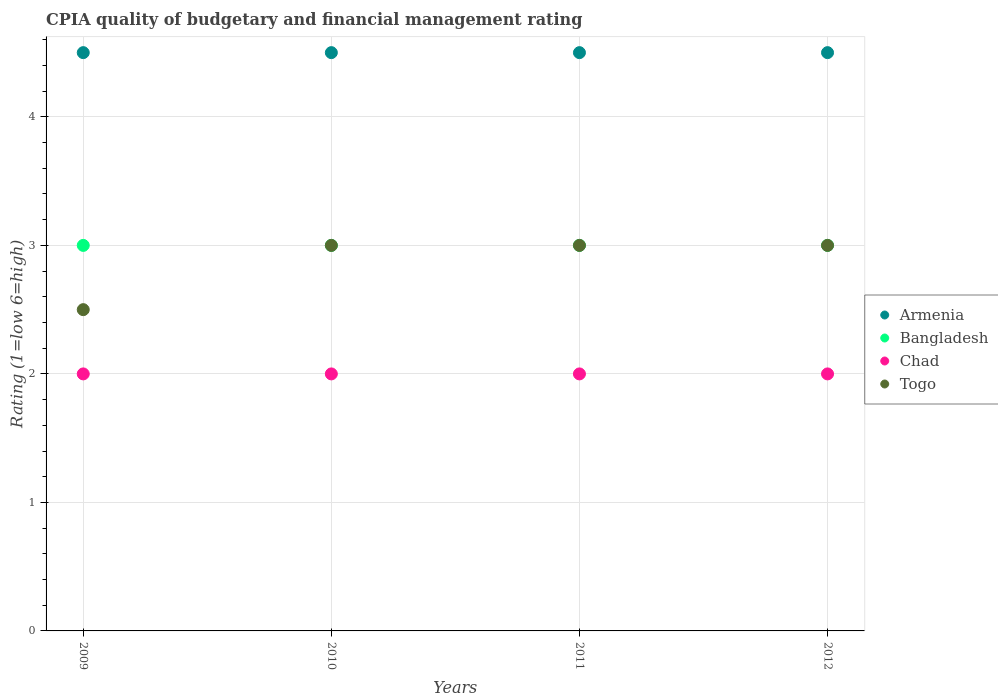Is the number of dotlines equal to the number of legend labels?
Keep it short and to the point. Yes. Across all years, what is the maximum CPIA rating in Togo?
Offer a very short reply. 3. Across all years, what is the minimum CPIA rating in Bangladesh?
Keep it short and to the point. 3. What is the total CPIA rating in Bangladesh in the graph?
Make the answer very short. 12. What is the difference between the CPIA rating in Bangladesh in 2011 and that in 2012?
Give a very brief answer. 0. What is the difference between the highest and the second highest CPIA rating in Togo?
Give a very brief answer. 0. In how many years, is the CPIA rating in Chad greater than the average CPIA rating in Chad taken over all years?
Your answer should be compact. 0. Is it the case that in every year, the sum of the CPIA rating in Chad and CPIA rating in Togo  is greater than the CPIA rating in Bangladesh?
Make the answer very short. Yes. Does the CPIA rating in Armenia monotonically increase over the years?
Ensure brevity in your answer.  No. Is the CPIA rating in Armenia strictly greater than the CPIA rating in Chad over the years?
Offer a very short reply. Yes. Is the CPIA rating in Bangladesh strictly less than the CPIA rating in Chad over the years?
Your answer should be very brief. No. How many dotlines are there?
Your answer should be compact. 4. How many years are there in the graph?
Your response must be concise. 4. Are the values on the major ticks of Y-axis written in scientific E-notation?
Provide a short and direct response. No. Does the graph contain grids?
Ensure brevity in your answer.  Yes. Where does the legend appear in the graph?
Your answer should be very brief. Center right. How many legend labels are there?
Provide a short and direct response. 4. What is the title of the graph?
Provide a succinct answer. CPIA quality of budgetary and financial management rating. What is the Rating (1=low 6=high) of Bangladesh in 2009?
Keep it short and to the point. 3. What is the Rating (1=low 6=high) of Chad in 2009?
Give a very brief answer. 2. What is the Rating (1=low 6=high) of Chad in 2010?
Offer a very short reply. 2. What is the Rating (1=low 6=high) of Togo in 2010?
Make the answer very short. 3. What is the Rating (1=low 6=high) of Bangladesh in 2011?
Offer a very short reply. 3. What is the Rating (1=low 6=high) in Togo in 2011?
Offer a terse response. 3. What is the Rating (1=low 6=high) of Armenia in 2012?
Your response must be concise. 4.5. Across all years, what is the maximum Rating (1=low 6=high) in Armenia?
Give a very brief answer. 4.5. Across all years, what is the maximum Rating (1=low 6=high) of Bangladesh?
Give a very brief answer. 3. Across all years, what is the maximum Rating (1=low 6=high) in Chad?
Offer a terse response. 2. Across all years, what is the maximum Rating (1=low 6=high) of Togo?
Provide a short and direct response. 3. Across all years, what is the minimum Rating (1=low 6=high) of Bangladesh?
Provide a succinct answer. 3. Across all years, what is the minimum Rating (1=low 6=high) in Chad?
Offer a very short reply. 2. What is the total Rating (1=low 6=high) of Togo in the graph?
Ensure brevity in your answer.  11.5. What is the difference between the Rating (1=low 6=high) of Armenia in 2009 and that in 2010?
Provide a short and direct response. 0. What is the difference between the Rating (1=low 6=high) of Chad in 2009 and that in 2010?
Offer a very short reply. 0. What is the difference between the Rating (1=low 6=high) in Bangladesh in 2009 and that in 2011?
Give a very brief answer. 0. What is the difference between the Rating (1=low 6=high) in Chad in 2009 and that in 2011?
Ensure brevity in your answer.  0. What is the difference between the Rating (1=low 6=high) of Togo in 2009 and that in 2011?
Provide a succinct answer. -0.5. What is the difference between the Rating (1=low 6=high) of Armenia in 2009 and that in 2012?
Offer a very short reply. 0. What is the difference between the Rating (1=low 6=high) of Bangladesh in 2009 and that in 2012?
Offer a very short reply. 0. What is the difference between the Rating (1=low 6=high) in Togo in 2009 and that in 2012?
Your answer should be compact. -0.5. What is the difference between the Rating (1=low 6=high) in Bangladesh in 2010 and that in 2011?
Provide a short and direct response. 0. What is the difference between the Rating (1=low 6=high) of Chad in 2010 and that in 2011?
Offer a very short reply. 0. What is the difference between the Rating (1=low 6=high) of Togo in 2010 and that in 2011?
Your answer should be very brief. 0. What is the difference between the Rating (1=low 6=high) of Togo in 2010 and that in 2012?
Offer a terse response. 0. What is the difference between the Rating (1=low 6=high) in Armenia in 2009 and the Rating (1=low 6=high) in Togo in 2010?
Your response must be concise. 1.5. What is the difference between the Rating (1=low 6=high) of Chad in 2009 and the Rating (1=low 6=high) of Togo in 2010?
Provide a succinct answer. -1. What is the difference between the Rating (1=low 6=high) of Armenia in 2009 and the Rating (1=low 6=high) of Chad in 2012?
Make the answer very short. 2.5. What is the difference between the Rating (1=low 6=high) of Bangladesh in 2009 and the Rating (1=low 6=high) of Togo in 2012?
Your response must be concise. 0. What is the difference between the Rating (1=low 6=high) in Bangladesh in 2010 and the Rating (1=low 6=high) in Chad in 2011?
Offer a terse response. 1. What is the difference between the Rating (1=low 6=high) in Chad in 2010 and the Rating (1=low 6=high) in Togo in 2011?
Provide a succinct answer. -1. What is the difference between the Rating (1=low 6=high) of Armenia in 2010 and the Rating (1=low 6=high) of Bangladesh in 2012?
Provide a short and direct response. 1.5. What is the difference between the Rating (1=low 6=high) in Armenia in 2010 and the Rating (1=low 6=high) in Chad in 2012?
Provide a succinct answer. 2.5. What is the difference between the Rating (1=low 6=high) in Bangladesh in 2010 and the Rating (1=low 6=high) in Chad in 2012?
Provide a short and direct response. 1. What is the difference between the Rating (1=low 6=high) in Bangladesh in 2010 and the Rating (1=low 6=high) in Togo in 2012?
Your answer should be very brief. 0. What is the difference between the Rating (1=low 6=high) in Armenia in 2011 and the Rating (1=low 6=high) in Chad in 2012?
Provide a succinct answer. 2.5. What is the difference between the Rating (1=low 6=high) of Bangladesh in 2011 and the Rating (1=low 6=high) of Togo in 2012?
Provide a short and direct response. 0. What is the difference between the Rating (1=low 6=high) of Chad in 2011 and the Rating (1=low 6=high) of Togo in 2012?
Your answer should be compact. -1. What is the average Rating (1=low 6=high) of Armenia per year?
Offer a terse response. 4.5. What is the average Rating (1=low 6=high) of Bangladesh per year?
Offer a terse response. 3. What is the average Rating (1=low 6=high) in Togo per year?
Ensure brevity in your answer.  2.88. In the year 2009, what is the difference between the Rating (1=low 6=high) of Armenia and Rating (1=low 6=high) of Togo?
Provide a succinct answer. 2. In the year 2009, what is the difference between the Rating (1=low 6=high) in Bangladesh and Rating (1=low 6=high) in Chad?
Offer a terse response. 1. In the year 2009, what is the difference between the Rating (1=low 6=high) of Bangladesh and Rating (1=low 6=high) of Togo?
Give a very brief answer. 0.5. In the year 2009, what is the difference between the Rating (1=low 6=high) in Chad and Rating (1=low 6=high) in Togo?
Provide a short and direct response. -0.5. In the year 2010, what is the difference between the Rating (1=low 6=high) of Bangladesh and Rating (1=low 6=high) of Chad?
Keep it short and to the point. 1. In the year 2010, what is the difference between the Rating (1=low 6=high) in Bangladesh and Rating (1=low 6=high) in Togo?
Provide a short and direct response. 0. In the year 2010, what is the difference between the Rating (1=low 6=high) in Chad and Rating (1=low 6=high) in Togo?
Provide a short and direct response. -1. In the year 2011, what is the difference between the Rating (1=low 6=high) in Armenia and Rating (1=low 6=high) in Bangladesh?
Keep it short and to the point. 1.5. In the year 2011, what is the difference between the Rating (1=low 6=high) of Armenia and Rating (1=low 6=high) of Chad?
Your response must be concise. 2.5. In the year 2011, what is the difference between the Rating (1=low 6=high) of Armenia and Rating (1=low 6=high) of Togo?
Make the answer very short. 1.5. In the year 2011, what is the difference between the Rating (1=low 6=high) in Chad and Rating (1=low 6=high) in Togo?
Make the answer very short. -1. In the year 2012, what is the difference between the Rating (1=low 6=high) in Armenia and Rating (1=low 6=high) in Chad?
Provide a succinct answer. 2.5. What is the ratio of the Rating (1=low 6=high) in Armenia in 2009 to that in 2010?
Your answer should be compact. 1. What is the ratio of the Rating (1=low 6=high) in Bangladesh in 2009 to that in 2010?
Keep it short and to the point. 1. What is the ratio of the Rating (1=low 6=high) of Togo in 2009 to that in 2010?
Provide a short and direct response. 0.83. What is the ratio of the Rating (1=low 6=high) of Bangladesh in 2009 to that in 2011?
Offer a very short reply. 1. What is the ratio of the Rating (1=low 6=high) of Chad in 2009 to that in 2011?
Offer a terse response. 1. What is the ratio of the Rating (1=low 6=high) of Armenia in 2009 to that in 2012?
Your answer should be compact. 1. What is the ratio of the Rating (1=low 6=high) in Bangladesh in 2009 to that in 2012?
Your answer should be very brief. 1. What is the ratio of the Rating (1=low 6=high) of Togo in 2009 to that in 2012?
Keep it short and to the point. 0.83. What is the ratio of the Rating (1=low 6=high) of Armenia in 2010 to that in 2012?
Ensure brevity in your answer.  1. What is the ratio of the Rating (1=low 6=high) in Bangladesh in 2010 to that in 2012?
Provide a succinct answer. 1. What is the ratio of the Rating (1=low 6=high) in Chad in 2010 to that in 2012?
Your response must be concise. 1. What is the ratio of the Rating (1=low 6=high) in Togo in 2010 to that in 2012?
Your answer should be compact. 1. What is the ratio of the Rating (1=low 6=high) in Armenia in 2011 to that in 2012?
Offer a terse response. 1. What is the ratio of the Rating (1=low 6=high) in Bangladesh in 2011 to that in 2012?
Give a very brief answer. 1. What is the ratio of the Rating (1=low 6=high) of Chad in 2011 to that in 2012?
Provide a short and direct response. 1. What is the difference between the highest and the second highest Rating (1=low 6=high) in Chad?
Make the answer very short. 0. What is the difference between the highest and the lowest Rating (1=low 6=high) of Armenia?
Ensure brevity in your answer.  0. What is the difference between the highest and the lowest Rating (1=low 6=high) in Bangladesh?
Your response must be concise. 0. What is the difference between the highest and the lowest Rating (1=low 6=high) in Togo?
Provide a succinct answer. 0.5. 